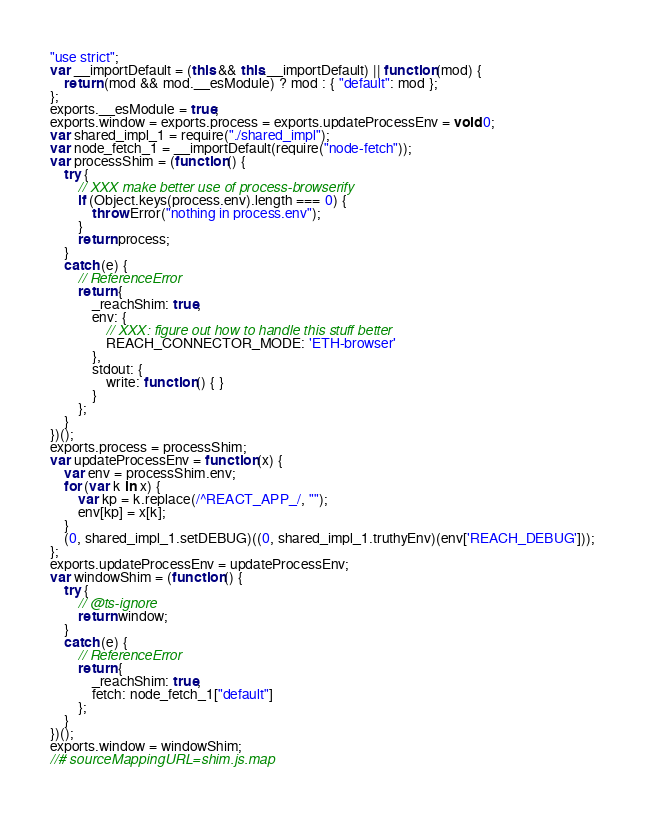<code> <loc_0><loc_0><loc_500><loc_500><_JavaScript_>"use strict";
var __importDefault = (this && this.__importDefault) || function (mod) {
    return (mod && mod.__esModule) ? mod : { "default": mod };
};
exports.__esModule = true;
exports.window = exports.process = exports.updateProcessEnv = void 0;
var shared_impl_1 = require("./shared_impl");
var node_fetch_1 = __importDefault(require("node-fetch"));
var processShim = (function () {
    try {
        // XXX make better use of process-browserify
        if (Object.keys(process.env).length === 0) {
            throw Error("nothing in process.env");
        }
        return process;
    }
    catch (e) {
        // ReferenceError
        return {
            _reachShim: true,
            env: {
                // XXX: figure out how to handle this stuff better
                REACH_CONNECTOR_MODE: 'ETH-browser'
            },
            stdout: {
                write: function () { }
            }
        };
    }
})();
exports.process = processShim;
var updateProcessEnv = function (x) {
    var env = processShim.env;
    for (var k in x) {
        var kp = k.replace(/^REACT_APP_/, "");
        env[kp] = x[k];
    }
    (0, shared_impl_1.setDEBUG)((0, shared_impl_1.truthyEnv)(env['REACH_DEBUG']));
};
exports.updateProcessEnv = updateProcessEnv;
var windowShim = (function () {
    try {
        // @ts-ignore
        return window;
    }
    catch (e) {
        // ReferenceError
        return {
            _reachShim: true,
            fetch: node_fetch_1["default"]
        };
    }
})();
exports.window = windowShim;
//# sourceMappingURL=shim.js.map</code> 